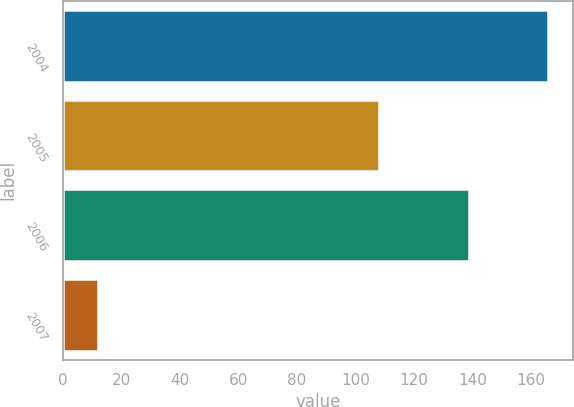<chart> <loc_0><loc_0><loc_500><loc_500><bar_chart><fcel>2004<fcel>2005<fcel>2006<fcel>2007<nl><fcel>166<fcel>108<fcel>139<fcel>12<nl></chart> 